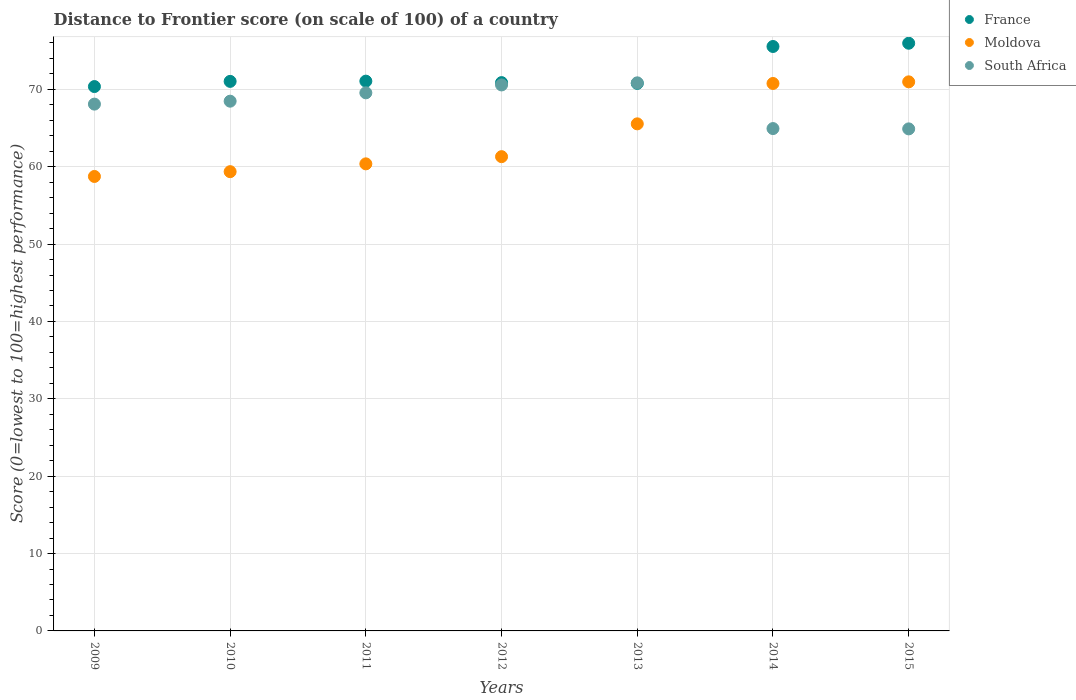What is the distance to frontier score of in France in 2013?
Make the answer very short. 70.77. Across all years, what is the maximum distance to frontier score of in South Africa?
Ensure brevity in your answer.  70.84. Across all years, what is the minimum distance to frontier score of in France?
Your response must be concise. 70.36. In which year was the distance to frontier score of in South Africa maximum?
Provide a short and direct response. 2013. In which year was the distance to frontier score of in South Africa minimum?
Provide a succinct answer. 2015. What is the total distance to frontier score of in South Africa in the graph?
Make the answer very short. 477.34. What is the difference between the distance to frontier score of in Moldova in 2011 and that in 2012?
Offer a very short reply. -0.93. What is the difference between the distance to frontier score of in Moldova in 2011 and the distance to frontier score of in South Africa in 2010?
Ensure brevity in your answer.  -8.1. What is the average distance to frontier score of in France per year?
Offer a terse response. 72.23. In the year 2010, what is the difference between the distance to frontier score of in France and distance to frontier score of in Moldova?
Your answer should be very brief. 11.67. What is the ratio of the distance to frontier score of in South Africa in 2010 to that in 2012?
Give a very brief answer. 0.97. What is the difference between the highest and the second highest distance to frontier score of in South Africa?
Provide a succinct answer. 0.27. What is the difference between the highest and the lowest distance to frontier score of in South Africa?
Your answer should be compact. 5.95. Is it the case that in every year, the sum of the distance to frontier score of in South Africa and distance to frontier score of in France  is greater than the distance to frontier score of in Moldova?
Your response must be concise. Yes. Does the distance to frontier score of in Moldova monotonically increase over the years?
Offer a terse response. Yes. Is the distance to frontier score of in Moldova strictly greater than the distance to frontier score of in South Africa over the years?
Make the answer very short. No. Is the distance to frontier score of in Moldova strictly less than the distance to frontier score of in South Africa over the years?
Make the answer very short. No. Does the graph contain any zero values?
Provide a short and direct response. No. How are the legend labels stacked?
Offer a very short reply. Vertical. What is the title of the graph?
Provide a succinct answer. Distance to Frontier score (on scale of 100) of a country. What is the label or title of the Y-axis?
Your response must be concise. Score (0=lowest to 100=highest performance). What is the Score (0=lowest to 100=highest performance) in France in 2009?
Your answer should be very brief. 70.36. What is the Score (0=lowest to 100=highest performance) in Moldova in 2009?
Offer a terse response. 58.74. What is the Score (0=lowest to 100=highest performance) in South Africa in 2009?
Provide a short and direct response. 68.09. What is the Score (0=lowest to 100=highest performance) of France in 2010?
Offer a very short reply. 71.03. What is the Score (0=lowest to 100=highest performance) of Moldova in 2010?
Make the answer very short. 59.36. What is the Score (0=lowest to 100=highest performance) of South Africa in 2010?
Offer a very short reply. 68.47. What is the Score (0=lowest to 100=highest performance) of France in 2011?
Provide a succinct answer. 71.06. What is the Score (0=lowest to 100=highest performance) of Moldova in 2011?
Give a very brief answer. 60.37. What is the Score (0=lowest to 100=highest performance) in South Africa in 2011?
Provide a succinct answer. 69.55. What is the Score (0=lowest to 100=highest performance) of France in 2012?
Your response must be concise. 70.87. What is the Score (0=lowest to 100=highest performance) of Moldova in 2012?
Provide a short and direct response. 61.3. What is the Score (0=lowest to 100=highest performance) in South Africa in 2012?
Keep it short and to the point. 70.57. What is the Score (0=lowest to 100=highest performance) of France in 2013?
Provide a succinct answer. 70.77. What is the Score (0=lowest to 100=highest performance) in Moldova in 2013?
Your answer should be very brief. 65.54. What is the Score (0=lowest to 100=highest performance) in South Africa in 2013?
Your answer should be compact. 70.84. What is the Score (0=lowest to 100=highest performance) of France in 2014?
Give a very brief answer. 75.54. What is the Score (0=lowest to 100=highest performance) in Moldova in 2014?
Offer a terse response. 70.76. What is the Score (0=lowest to 100=highest performance) in South Africa in 2014?
Your answer should be very brief. 64.93. What is the Score (0=lowest to 100=highest performance) of France in 2015?
Provide a short and direct response. 75.96. What is the Score (0=lowest to 100=highest performance) of Moldova in 2015?
Give a very brief answer. 70.97. What is the Score (0=lowest to 100=highest performance) in South Africa in 2015?
Give a very brief answer. 64.89. Across all years, what is the maximum Score (0=lowest to 100=highest performance) in France?
Keep it short and to the point. 75.96. Across all years, what is the maximum Score (0=lowest to 100=highest performance) in Moldova?
Your answer should be compact. 70.97. Across all years, what is the maximum Score (0=lowest to 100=highest performance) of South Africa?
Make the answer very short. 70.84. Across all years, what is the minimum Score (0=lowest to 100=highest performance) in France?
Make the answer very short. 70.36. Across all years, what is the minimum Score (0=lowest to 100=highest performance) of Moldova?
Provide a succinct answer. 58.74. Across all years, what is the minimum Score (0=lowest to 100=highest performance) of South Africa?
Give a very brief answer. 64.89. What is the total Score (0=lowest to 100=highest performance) in France in the graph?
Make the answer very short. 505.59. What is the total Score (0=lowest to 100=highest performance) in Moldova in the graph?
Provide a succinct answer. 447.04. What is the total Score (0=lowest to 100=highest performance) in South Africa in the graph?
Keep it short and to the point. 477.34. What is the difference between the Score (0=lowest to 100=highest performance) in France in 2009 and that in 2010?
Your answer should be compact. -0.67. What is the difference between the Score (0=lowest to 100=highest performance) of Moldova in 2009 and that in 2010?
Make the answer very short. -0.62. What is the difference between the Score (0=lowest to 100=highest performance) of South Africa in 2009 and that in 2010?
Your response must be concise. -0.38. What is the difference between the Score (0=lowest to 100=highest performance) in France in 2009 and that in 2011?
Provide a short and direct response. -0.7. What is the difference between the Score (0=lowest to 100=highest performance) in Moldova in 2009 and that in 2011?
Ensure brevity in your answer.  -1.63. What is the difference between the Score (0=lowest to 100=highest performance) of South Africa in 2009 and that in 2011?
Provide a short and direct response. -1.46. What is the difference between the Score (0=lowest to 100=highest performance) in France in 2009 and that in 2012?
Give a very brief answer. -0.51. What is the difference between the Score (0=lowest to 100=highest performance) in Moldova in 2009 and that in 2012?
Your response must be concise. -2.56. What is the difference between the Score (0=lowest to 100=highest performance) of South Africa in 2009 and that in 2012?
Keep it short and to the point. -2.48. What is the difference between the Score (0=lowest to 100=highest performance) of France in 2009 and that in 2013?
Make the answer very short. -0.41. What is the difference between the Score (0=lowest to 100=highest performance) in South Africa in 2009 and that in 2013?
Your response must be concise. -2.75. What is the difference between the Score (0=lowest to 100=highest performance) in France in 2009 and that in 2014?
Your response must be concise. -5.18. What is the difference between the Score (0=lowest to 100=highest performance) of Moldova in 2009 and that in 2014?
Give a very brief answer. -12.02. What is the difference between the Score (0=lowest to 100=highest performance) of South Africa in 2009 and that in 2014?
Give a very brief answer. 3.16. What is the difference between the Score (0=lowest to 100=highest performance) of Moldova in 2009 and that in 2015?
Your answer should be compact. -12.23. What is the difference between the Score (0=lowest to 100=highest performance) in South Africa in 2009 and that in 2015?
Your answer should be very brief. 3.2. What is the difference between the Score (0=lowest to 100=highest performance) in France in 2010 and that in 2011?
Your response must be concise. -0.03. What is the difference between the Score (0=lowest to 100=highest performance) of Moldova in 2010 and that in 2011?
Your answer should be very brief. -1.01. What is the difference between the Score (0=lowest to 100=highest performance) of South Africa in 2010 and that in 2011?
Ensure brevity in your answer.  -1.08. What is the difference between the Score (0=lowest to 100=highest performance) in France in 2010 and that in 2012?
Keep it short and to the point. 0.16. What is the difference between the Score (0=lowest to 100=highest performance) in Moldova in 2010 and that in 2012?
Provide a short and direct response. -1.94. What is the difference between the Score (0=lowest to 100=highest performance) of France in 2010 and that in 2013?
Provide a succinct answer. 0.26. What is the difference between the Score (0=lowest to 100=highest performance) in Moldova in 2010 and that in 2013?
Keep it short and to the point. -6.18. What is the difference between the Score (0=lowest to 100=highest performance) of South Africa in 2010 and that in 2013?
Provide a short and direct response. -2.37. What is the difference between the Score (0=lowest to 100=highest performance) in France in 2010 and that in 2014?
Keep it short and to the point. -4.51. What is the difference between the Score (0=lowest to 100=highest performance) in Moldova in 2010 and that in 2014?
Provide a succinct answer. -11.4. What is the difference between the Score (0=lowest to 100=highest performance) of South Africa in 2010 and that in 2014?
Provide a short and direct response. 3.54. What is the difference between the Score (0=lowest to 100=highest performance) in France in 2010 and that in 2015?
Offer a terse response. -4.93. What is the difference between the Score (0=lowest to 100=highest performance) of Moldova in 2010 and that in 2015?
Offer a very short reply. -11.61. What is the difference between the Score (0=lowest to 100=highest performance) in South Africa in 2010 and that in 2015?
Make the answer very short. 3.58. What is the difference between the Score (0=lowest to 100=highest performance) of France in 2011 and that in 2012?
Your answer should be very brief. 0.19. What is the difference between the Score (0=lowest to 100=highest performance) of Moldova in 2011 and that in 2012?
Make the answer very short. -0.93. What is the difference between the Score (0=lowest to 100=highest performance) in South Africa in 2011 and that in 2012?
Your response must be concise. -1.02. What is the difference between the Score (0=lowest to 100=highest performance) in France in 2011 and that in 2013?
Your answer should be compact. 0.29. What is the difference between the Score (0=lowest to 100=highest performance) in Moldova in 2011 and that in 2013?
Provide a short and direct response. -5.17. What is the difference between the Score (0=lowest to 100=highest performance) in South Africa in 2011 and that in 2013?
Your answer should be very brief. -1.29. What is the difference between the Score (0=lowest to 100=highest performance) in France in 2011 and that in 2014?
Your answer should be compact. -4.48. What is the difference between the Score (0=lowest to 100=highest performance) in Moldova in 2011 and that in 2014?
Provide a succinct answer. -10.39. What is the difference between the Score (0=lowest to 100=highest performance) in South Africa in 2011 and that in 2014?
Your answer should be very brief. 4.62. What is the difference between the Score (0=lowest to 100=highest performance) in South Africa in 2011 and that in 2015?
Provide a succinct answer. 4.66. What is the difference between the Score (0=lowest to 100=highest performance) in Moldova in 2012 and that in 2013?
Your response must be concise. -4.24. What is the difference between the Score (0=lowest to 100=highest performance) in South Africa in 2012 and that in 2013?
Keep it short and to the point. -0.27. What is the difference between the Score (0=lowest to 100=highest performance) of France in 2012 and that in 2014?
Keep it short and to the point. -4.67. What is the difference between the Score (0=lowest to 100=highest performance) of Moldova in 2012 and that in 2014?
Give a very brief answer. -9.46. What is the difference between the Score (0=lowest to 100=highest performance) in South Africa in 2012 and that in 2014?
Your answer should be very brief. 5.64. What is the difference between the Score (0=lowest to 100=highest performance) in France in 2012 and that in 2015?
Your response must be concise. -5.09. What is the difference between the Score (0=lowest to 100=highest performance) in Moldova in 2012 and that in 2015?
Make the answer very short. -9.67. What is the difference between the Score (0=lowest to 100=highest performance) in South Africa in 2012 and that in 2015?
Offer a terse response. 5.68. What is the difference between the Score (0=lowest to 100=highest performance) in France in 2013 and that in 2014?
Make the answer very short. -4.77. What is the difference between the Score (0=lowest to 100=highest performance) of Moldova in 2013 and that in 2014?
Give a very brief answer. -5.22. What is the difference between the Score (0=lowest to 100=highest performance) of South Africa in 2013 and that in 2014?
Make the answer very short. 5.91. What is the difference between the Score (0=lowest to 100=highest performance) in France in 2013 and that in 2015?
Offer a terse response. -5.19. What is the difference between the Score (0=lowest to 100=highest performance) in Moldova in 2013 and that in 2015?
Offer a very short reply. -5.43. What is the difference between the Score (0=lowest to 100=highest performance) of South Africa in 2013 and that in 2015?
Offer a very short reply. 5.95. What is the difference between the Score (0=lowest to 100=highest performance) of France in 2014 and that in 2015?
Your answer should be compact. -0.42. What is the difference between the Score (0=lowest to 100=highest performance) in Moldova in 2014 and that in 2015?
Make the answer very short. -0.21. What is the difference between the Score (0=lowest to 100=highest performance) of South Africa in 2014 and that in 2015?
Your answer should be compact. 0.04. What is the difference between the Score (0=lowest to 100=highest performance) of France in 2009 and the Score (0=lowest to 100=highest performance) of Moldova in 2010?
Provide a short and direct response. 11. What is the difference between the Score (0=lowest to 100=highest performance) in France in 2009 and the Score (0=lowest to 100=highest performance) in South Africa in 2010?
Offer a terse response. 1.89. What is the difference between the Score (0=lowest to 100=highest performance) in Moldova in 2009 and the Score (0=lowest to 100=highest performance) in South Africa in 2010?
Make the answer very short. -9.73. What is the difference between the Score (0=lowest to 100=highest performance) of France in 2009 and the Score (0=lowest to 100=highest performance) of Moldova in 2011?
Give a very brief answer. 9.99. What is the difference between the Score (0=lowest to 100=highest performance) of France in 2009 and the Score (0=lowest to 100=highest performance) of South Africa in 2011?
Provide a succinct answer. 0.81. What is the difference between the Score (0=lowest to 100=highest performance) of Moldova in 2009 and the Score (0=lowest to 100=highest performance) of South Africa in 2011?
Offer a very short reply. -10.81. What is the difference between the Score (0=lowest to 100=highest performance) in France in 2009 and the Score (0=lowest to 100=highest performance) in Moldova in 2012?
Provide a short and direct response. 9.06. What is the difference between the Score (0=lowest to 100=highest performance) in France in 2009 and the Score (0=lowest to 100=highest performance) in South Africa in 2012?
Ensure brevity in your answer.  -0.21. What is the difference between the Score (0=lowest to 100=highest performance) in Moldova in 2009 and the Score (0=lowest to 100=highest performance) in South Africa in 2012?
Your answer should be compact. -11.83. What is the difference between the Score (0=lowest to 100=highest performance) in France in 2009 and the Score (0=lowest to 100=highest performance) in Moldova in 2013?
Your answer should be compact. 4.82. What is the difference between the Score (0=lowest to 100=highest performance) of France in 2009 and the Score (0=lowest to 100=highest performance) of South Africa in 2013?
Give a very brief answer. -0.48. What is the difference between the Score (0=lowest to 100=highest performance) of Moldova in 2009 and the Score (0=lowest to 100=highest performance) of South Africa in 2013?
Ensure brevity in your answer.  -12.1. What is the difference between the Score (0=lowest to 100=highest performance) in France in 2009 and the Score (0=lowest to 100=highest performance) in South Africa in 2014?
Give a very brief answer. 5.43. What is the difference between the Score (0=lowest to 100=highest performance) in Moldova in 2009 and the Score (0=lowest to 100=highest performance) in South Africa in 2014?
Provide a succinct answer. -6.19. What is the difference between the Score (0=lowest to 100=highest performance) of France in 2009 and the Score (0=lowest to 100=highest performance) of Moldova in 2015?
Your answer should be compact. -0.61. What is the difference between the Score (0=lowest to 100=highest performance) in France in 2009 and the Score (0=lowest to 100=highest performance) in South Africa in 2015?
Give a very brief answer. 5.47. What is the difference between the Score (0=lowest to 100=highest performance) in Moldova in 2009 and the Score (0=lowest to 100=highest performance) in South Africa in 2015?
Your answer should be compact. -6.15. What is the difference between the Score (0=lowest to 100=highest performance) of France in 2010 and the Score (0=lowest to 100=highest performance) of Moldova in 2011?
Your response must be concise. 10.66. What is the difference between the Score (0=lowest to 100=highest performance) of France in 2010 and the Score (0=lowest to 100=highest performance) of South Africa in 2011?
Ensure brevity in your answer.  1.48. What is the difference between the Score (0=lowest to 100=highest performance) in Moldova in 2010 and the Score (0=lowest to 100=highest performance) in South Africa in 2011?
Your answer should be compact. -10.19. What is the difference between the Score (0=lowest to 100=highest performance) of France in 2010 and the Score (0=lowest to 100=highest performance) of Moldova in 2012?
Give a very brief answer. 9.73. What is the difference between the Score (0=lowest to 100=highest performance) of France in 2010 and the Score (0=lowest to 100=highest performance) of South Africa in 2012?
Provide a short and direct response. 0.46. What is the difference between the Score (0=lowest to 100=highest performance) of Moldova in 2010 and the Score (0=lowest to 100=highest performance) of South Africa in 2012?
Offer a very short reply. -11.21. What is the difference between the Score (0=lowest to 100=highest performance) of France in 2010 and the Score (0=lowest to 100=highest performance) of Moldova in 2013?
Offer a terse response. 5.49. What is the difference between the Score (0=lowest to 100=highest performance) of France in 2010 and the Score (0=lowest to 100=highest performance) of South Africa in 2013?
Offer a very short reply. 0.19. What is the difference between the Score (0=lowest to 100=highest performance) of Moldova in 2010 and the Score (0=lowest to 100=highest performance) of South Africa in 2013?
Provide a short and direct response. -11.48. What is the difference between the Score (0=lowest to 100=highest performance) of France in 2010 and the Score (0=lowest to 100=highest performance) of Moldova in 2014?
Your answer should be very brief. 0.27. What is the difference between the Score (0=lowest to 100=highest performance) of Moldova in 2010 and the Score (0=lowest to 100=highest performance) of South Africa in 2014?
Keep it short and to the point. -5.57. What is the difference between the Score (0=lowest to 100=highest performance) in France in 2010 and the Score (0=lowest to 100=highest performance) in Moldova in 2015?
Keep it short and to the point. 0.06. What is the difference between the Score (0=lowest to 100=highest performance) of France in 2010 and the Score (0=lowest to 100=highest performance) of South Africa in 2015?
Offer a very short reply. 6.14. What is the difference between the Score (0=lowest to 100=highest performance) of Moldova in 2010 and the Score (0=lowest to 100=highest performance) of South Africa in 2015?
Make the answer very short. -5.53. What is the difference between the Score (0=lowest to 100=highest performance) in France in 2011 and the Score (0=lowest to 100=highest performance) in Moldova in 2012?
Your answer should be compact. 9.76. What is the difference between the Score (0=lowest to 100=highest performance) in France in 2011 and the Score (0=lowest to 100=highest performance) in South Africa in 2012?
Ensure brevity in your answer.  0.49. What is the difference between the Score (0=lowest to 100=highest performance) of Moldova in 2011 and the Score (0=lowest to 100=highest performance) of South Africa in 2012?
Make the answer very short. -10.2. What is the difference between the Score (0=lowest to 100=highest performance) of France in 2011 and the Score (0=lowest to 100=highest performance) of Moldova in 2013?
Your answer should be very brief. 5.52. What is the difference between the Score (0=lowest to 100=highest performance) of France in 2011 and the Score (0=lowest to 100=highest performance) of South Africa in 2013?
Provide a succinct answer. 0.22. What is the difference between the Score (0=lowest to 100=highest performance) of Moldova in 2011 and the Score (0=lowest to 100=highest performance) of South Africa in 2013?
Offer a terse response. -10.47. What is the difference between the Score (0=lowest to 100=highest performance) of France in 2011 and the Score (0=lowest to 100=highest performance) of Moldova in 2014?
Offer a very short reply. 0.3. What is the difference between the Score (0=lowest to 100=highest performance) in France in 2011 and the Score (0=lowest to 100=highest performance) in South Africa in 2014?
Your response must be concise. 6.13. What is the difference between the Score (0=lowest to 100=highest performance) of Moldova in 2011 and the Score (0=lowest to 100=highest performance) of South Africa in 2014?
Ensure brevity in your answer.  -4.56. What is the difference between the Score (0=lowest to 100=highest performance) of France in 2011 and the Score (0=lowest to 100=highest performance) of Moldova in 2015?
Keep it short and to the point. 0.09. What is the difference between the Score (0=lowest to 100=highest performance) of France in 2011 and the Score (0=lowest to 100=highest performance) of South Africa in 2015?
Your answer should be very brief. 6.17. What is the difference between the Score (0=lowest to 100=highest performance) of Moldova in 2011 and the Score (0=lowest to 100=highest performance) of South Africa in 2015?
Your answer should be very brief. -4.52. What is the difference between the Score (0=lowest to 100=highest performance) of France in 2012 and the Score (0=lowest to 100=highest performance) of Moldova in 2013?
Your answer should be very brief. 5.33. What is the difference between the Score (0=lowest to 100=highest performance) in Moldova in 2012 and the Score (0=lowest to 100=highest performance) in South Africa in 2013?
Provide a short and direct response. -9.54. What is the difference between the Score (0=lowest to 100=highest performance) in France in 2012 and the Score (0=lowest to 100=highest performance) in Moldova in 2014?
Make the answer very short. 0.11. What is the difference between the Score (0=lowest to 100=highest performance) of France in 2012 and the Score (0=lowest to 100=highest performance) of South Africa in 2014?
Offer a terse response. 5.94. What is the difference between the Score (0=lowest to 100=highest performance) in Moldova in 2012 and the Score (0=lowest to 100=highest performance) in South Africa in 2014?
Your answer should be very brief. -3.63. What is the difference between the Score (0=lowest to 100=highest performance) of France in 2012 and the Score (0=lowest to 100=highest performance) of South Africa in 2015?
Provide a short and direct response. 5.98. What is the difference between the Score (0=lowest to 100=highest performance) of Moldova in 2012 and the Score (0=lowest to 100=highest performance) of South Africa in 2015?
Make the answer very short. -3.59. What is the difference between the Score (0=lowest to 100=highest performance) in France in 2013 and the Score (0=lowest to 100=highest performance) in South Africa in 2014?
Offer a very short reply. 5.84. What is the difference between the Score (0=lowest to 100=highest performance) of Moldova in 2013 and the Score (0=lowest to 100=highest performance) of South Africa in 2014?
Your answer should be compact. 0.61. What is the difference between the Score (0=lowest to 100=highest performance) of France in 2013 and the Score (0=lowest to 100=highest performance) of Moldova in 2015?
Offer a terse response. -0.2. What is the difference between the Score (0=lowest to 100=highest performance) in France in 2013 and the Score (0=lowest to 100=highest performance) in South Africa in 2015?
Offer a terse response. 5.88. What is the difference between the Score (0=lowest to 100=highest performance) in Moldova in 2013 and the Score (0=lowest to 100=highest performance) in South Africa in 2015?
Make the answer very short. 0.65. What is the difference between the Score (0=lowest to 100=highest performance) in France in 2014 and the Score (0=lowest to 100=highest performance) in Moldova in 2015?
Give a very brief answer. 4.57. What is the difference between the Score (0=lowest to 100=highest performance) in France in 2014 and the Score (0=lowest to 100=highest performance) in South Africa in 2015?
Provide a short and direct response. 10.65. What is the difference between the Score (0=lowest to 100=highest performance) in Moldova in 2014 and the Score (0=lowest to 100=highest performance) in South Africa in 2015?
Ensure brevity in your answer.  5.87. What is the average Score (0=lowest to 100=highest performance) of France per year?
Ensure brevity in your answer.  72.23. What is the average Score (0=lowest to 100=highest performance) in Moldova per year?
Your answer should be very brief. 63.86. What is the average Score (0=lowest to 100=highest performance) in South Africa per year?
Your answer should be compact. 68.19. In the year 2009, what is the difference between the Score (0=lowest to 100=highest performance) in France and Score (0=lowest to 100=highest performance) in Moldova?
Keep it short and to the point. 11.62. In the year 2009, what is the difference between the Score (0=lowest to 100=highest performance) of France and Score (0=lowest to 100=highest performance) of South Africa?
Make the answer very short. 2.27. In the year 2009, what is the difference between the Score (0=lowest to 100=highest performance) in Moldova and Score (0=lowest to 100=highest performance) in South Africa?
Your answer should be compact. -9.35. In the year 2010, what is the difference between the Score (0=lowest to 100=highest performance) of France and Score (0=lowest to 100=highest performance) of Moldova?
Provide a succinct answer. 11.67. In the year 2010, what is the difference between the Score (0=lowest to 100=highest performance) of France and Score (0=lowest to 100=highest performance) of South Africa?
Provide a succinct answer. 2.56. In the year 2010, what is the difference between the Score (0=lowest to 100=highest performance) of Moldova and Score (0=lowest to 100=highest performance) of South Africa?
Your answer should be compact. -9.11. In the year 2011, what is the difference between the Score (0=lowest to 100=highest performance) of France and Score (0=lowest to 100=highest performance) of Moldova?
Give a very brief answer. 10.69. In the year 2011, what is the difference between the Score (0=lowest to 100=highest performance) of France and Score (0=lowest to 100=highest performance) of South Africa?
Make the answer very short. 1.51. In the year 2011, what is the difference between the Score (0=lowest to 100=highest performance) of Moldova and Score (0=lowest to 100=highest performance) of South Africa?
Provide a succinct answer. -9.18. In the year 2012, what is the difference between the Score (0=lowest to 100=highest performance) in France and Score (0=lowest to 100=highest performance) in Moldova?
Keep it short and to the point. 9.57. In the year 2012, what is the difference between the Score (0=lowest to 100=highest performance) of Moldova and Score (0=lowest to 100=highest performance) of South Africa?
Your response must be concise. -9.27. In the year 2013, what is the difference between the Score (0=lowest to 100=highest performance) in France and Score (0=lowest to 100=highest performance) in Moldova?
Your answer should be very brief. 5.23. In the year 2013, what is the difference between the Score (0=lowest to 100=highest performance) in France and Score (0=lowest to 100=highest performance) in South Africa?
Your answer should be compact. -0.07. In the year 2014, what is the difference between the Score (0=lowest to 100=highest performance) in France and Score (0=lowest to 100=highest performance) in Moldova?
Your answer should be very brief. 4.78. In the year 2014, what is the difference between the Score (0=lowest to 100=highest performance) in France and Score (0=lowest to 100=highest performance) in South Africa?
Your answer should be compact. 10.61. In the year 2014, what is the difference between the Score (0=lowest to 100=highest performance) of Moldova and Score (0=lowest to 100=highest performance) of South Africa?
Your response must be concise. 5.83. In the year 2015, what is the difference between the Score (0=lowest to 100=highest performance) in France and Score (0=lowest to 100=highest performance) in Moldova?
Provide a short and direct response. 4.99. In the year 2015, what is the difference between the Score (0=lowest to 100=highest performance) in France and Score (0=lowest to 100=highest performance) in South Africa?
Ensure brevity in your answer.  11.07. In the year 2015, what is the difference between the Score (0=lowest to 100=highest performance) in Moldova and Score (0=lowest to 100=highest performance) in South Africa?
Offer a terse response. 6.08. What is the ratio of the Score (0=lowest to 100=highest performance) in France in 2009 to that in 2010?
Ensure brevity in your answer.  0.99. What is the ratio of the Score (0=lowest to 100=highest performance) in Moldova in 2009 to that in 2010?
Provide a succinct answer. 0.99. What is the ratio of the Score (0=lowest to 100=highest performance) in France in 2009 to that in 2011?
Your answer should be compact. 0.99. What is the ratio of the Score (0=lowest to 100=highest performance) of Moldova in 2009 to that in 2011?
Your answer should be compact. 0.97. What is the ratio of the Score (0=lowest to 100=highest performance) of France in 2009 to that in 2012?
Your answer should be compact. 0.99. What is the ratio of the Score (0=lowest to 100=highest performance) of Moldova in 2009 to that in 2012?
Give a very brief answer. 0.96. What is the ratio of the Score (0=lowest to 100=highest performance) in South Africa in 2009 to that in 2012?
Provide a short and direct response. 0.96. What is the ratio of the Score (0=lowest to 100=highest performance) in Moldova in 2009 to that in 2013?
Keep it short and to the point. 0.9. What is the ratio of the Score (0=lowest to 100=highest performance) of South Africa in 2009 to that in 2013?
Your answer should be compact. 0.96. What is the ratio of the Score (0=lowest to 100=highest performance) in France in 2009 to that in 2014?
Make the answer very short. 0.93. What is the ratio of the Score (0=lowest to 100=highest performance) of Moldova in 2009 to that in 2014?
Your response must be concise. 0.83. What is the ratio of the Score (0=lowest to 100=highest performance) in South Africa in 2009 to that in 2014?
Your response must be concise. 1.05. What is the ratio of the Score (0=lowest to 100=highest performance) of France in 2009 to that in 2015?
Ensure brevity in your answer.  0.93. What is the ratio of the Score (0=lowest to 100=highest performance) of Moldova in 2009 to that in 2015?
Give a very brief answer. 0.83. What is the ratio of the Score (0=lowest to 100=highest performance) in South Africa in 2009 to that in 2015?
Your answer should be compact. 1.05. What is the ratio of the Score (0=lowest to 100=highest performance) of Moldova in 2010 to that in 2011?
Provide a succinct answer. 0.98. What is the ratio of the Score (0=lowest to 100=highest performance) in South Africa in 2010 to that in 2011?
Keep it short and to the point. 0.98. What is the ratio of the Score (0=lowest to 100=highest performance) in France in 2010 to that in 2012?
Ensure brevity in your answer.  1. What is the ratio of the Score (0=lowest to 100=highest performance) of Moldova in 2010 to that in 2012?
Your answer should be very brief. 0.97. What is the ratio of the Score (0=lowest to 100=highest performance) of South Africa in 2010 to that in 2012?
Provide a short and direct response. 0.97. What is the ratio of the Score (0=lowest to 100=highest performance) in Moldova in 2010 to that in 2013?
Provide a short and direct response. 0.91. What is the ratio of the Score (0=lowest to 100=highest performance) of South Africa in 2010 to that in 2013?
Offer a terse response. 0.97. What is the ratio of the Score (0=lowest to 100=highest performance) of France in 2010 to that in 2014?
Provide a succinct answer. 0.94. What is the ratio of the Score (0=lowest to 100=highest performance) of Moldova in 2010 to that in 2014?
Give a very brief answer. 0.84. What is the ratio of the Score (0=lowest to 100=highest performance) in South Africa in 2010 to that in 2014?
Give a very brief answer. 1.05. What is the ratio of the Score (0=lowest to 100=highest performance) in France in 2010 to that in 2015?
Your answer should be very brief. 0.94. What is the ratio of the Score (0=lowest to 100=highest performance) of Moldova in 2010 to that in 2015?
Make the answer very short. 0.84. What is the ratio of the Score (0=lowest to 100=highest performance) of South Africa in 2010 to that in 2015?
Provide a succinct answer. 1.06. What is the ratio of the Score (0=lowest to 100=highest performance) in South Africa in 2011 to that in 2012?
Make the answer very short. 0.99. What is the ratio of the Score (0=lowest to 100=highest performance) in Moldova in 2011 to that in 2013?
Keep it short and to the point. 0.92. What is the ratio of the Score (0=lowest to 100=highest performance) in South Africa in 2011 to that in 2013?
Offer a very short reply. 0.98. What is the ratio of the Score (0=lowest to 100=highest performance) in France in 2011 to that in 2014?
Ensure brevity in your answer.  0.94. What is the ratio of the Score (0=lowest to 100=highest performance) in Moldova in 2011 to that in 2014?
Ensure brevity in your answer.  0.85. What is the ratio of the Score (0=lowest to 100=highest performance) in South Africa in 2011 to that in 2014?
Offer a very short reply. 1.07. What is the ratio of the Score (0=lowest to 100=highest performance) in France in 2011 to that in 2015?
Offer a very short reply. 0.94. What is the ratio of the Score (0=lowest to 100=highest performance) in Moldova in 2011 to that in 2015?
Your answer should be compact. 0.85. What is the ratio of the Score (0=lowest to 100=highest performance) of South Africa in 2011 to that in 2015?
Offer a terse response. 1.07. What is the ratio of the Score (0=lowest to 100=highest performance) in Moldova in 2012 to that in 2013?
Give a very brief answer. 0.94. What is the ratio of the Score (0=lowest to 100=highest performance) of France in 2012 to that in 2014?
Provide a short and direct response. 0.94. What is the ratio of the Score (0=lowest to 100=highest performance) of Moldova in 2012 to that in 2014?
Your answer should be compact. 0.87. What is the ratio of the Score (0=lowest to 100=highest performance) in South Africa in 2012 to that in 2014?
Offer a very short reply. 1.09. What is the ratio of the Score (0=lowest to 100=highest performance) in France in 2012 to that in 2015?
Provide a short and direct response. 0.93. What is the ratio of the Score (0=lowest to 100=highest performance) in Moldova in 2012 to that in 2015?
Provide a short and direct response. 0.86. What is the ratio of the Score (0=lowest to 100=highest performance) in South Africa in 2012 to that in 2015?
Offer a very short reply. 1.09. What is the ratio of the Score (0=lowest to 100=highest performance) in France in 2013 to that in 2014?
Provide a succinct answer. 0.94. What is the ratio of the Score (0=lowest to 100=highest performance) of Moldova in 2013 to that in 2014?
Make the answer very short. 0.93. What is the ratio of the Score (0=lowest to 100=highest performance) of South Africa in 2013 to that in 2014?
Offer a very short reply. 1.09. What is the ratio of the Score (0=lowest to 100=highest performance) of France in 2013 to that in 2015?
Your answer should be very brief. 0.93. What is the ratio of the Score (0=lowest to 100=highest performance) in Moldova in 2013 to that in 2015?
Offer a terse response. 0.92. What is the ratio of the Score (0=lowest to 100=highest performance) in South Africa in 2013 to that in 2015?
Make the answer very short. 1.09. What is the ratio of the Score (0=lowest to 100=highest performance) in Moldova in 2014 to that in 2015?
Your response must be concise. 1. What is the ratio of the Score (0=lowest to 100=highest performance) of South Africa in 2014 to that in 2015?
Ensure brevity in your answer.  1. What is the difference between the highest and the second highest Score (0=lowest to 100=highest performance) in France?
Your answer should be compact. 0.42. What is the difference between the highest and the second highest Score (0=lowest to 100=highest performance) of Moldova?
Your response must be concise. 0.21. What is the difference between the highest and the second highest Score (0=lowest to 100=highest performance) in South Africa?
Provide a short and direct response. 0.27. What is the difference between the highest and the lowest Score (0=lowest to 100=highest performance) in Moldova?
Your response must be concise. 12.23. What is the difference between the highest and the lowest Score (0=lowest to 100=highest performance) of South Africa?
Your response must be concise. 5.95. 